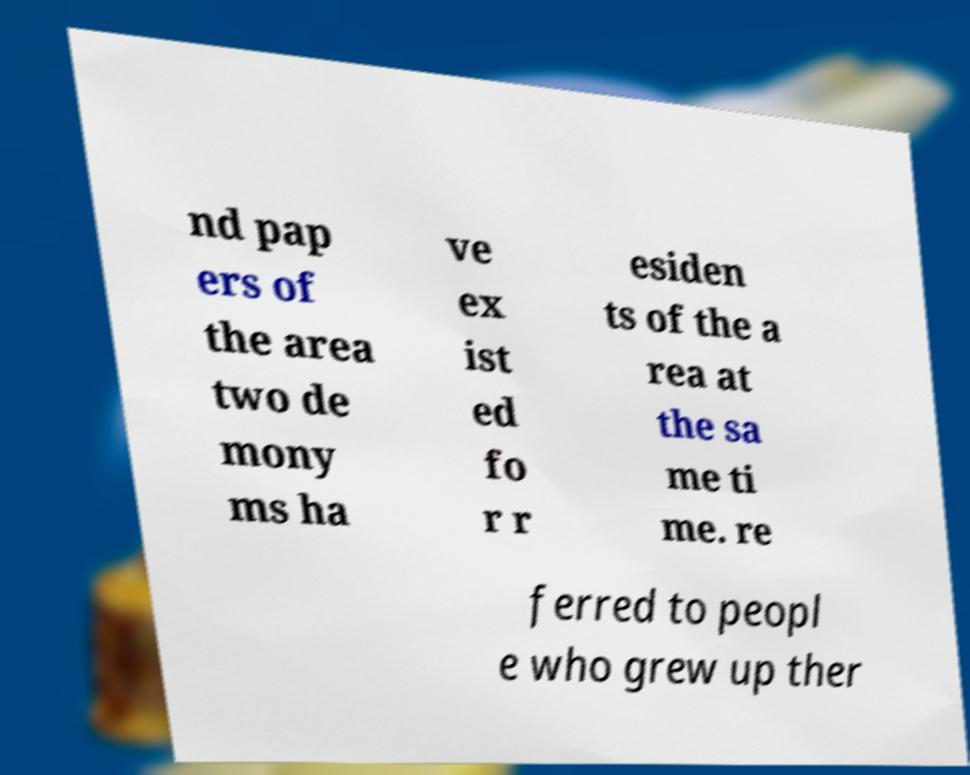Can you accurately transcribe the text from the provided image for me? nd pap ers of the area two de mony ms ha ve ex ist ed fo r r esiden ts of the a rea at the sa me ti me. re ferred to peopl e who grew up ther 